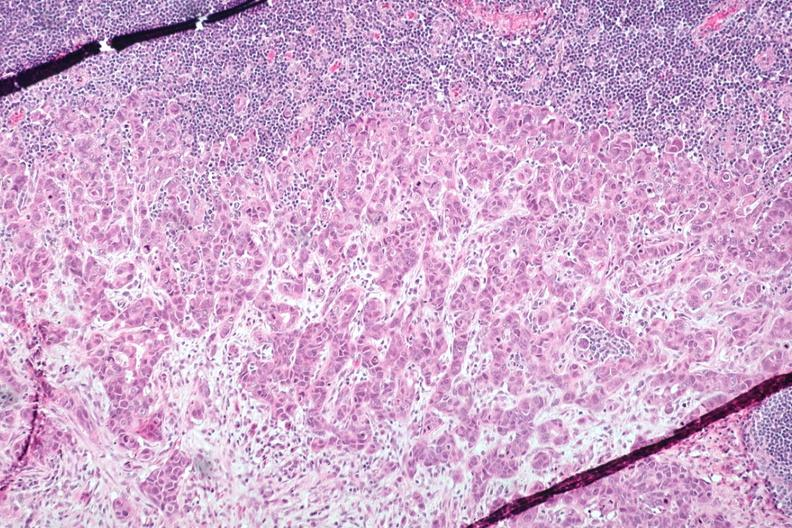does this image show med neoplastic ducts with desmoplastic reaction lymph node tissue atone margin and?
Answer the question using a single word or phrase. Yes 